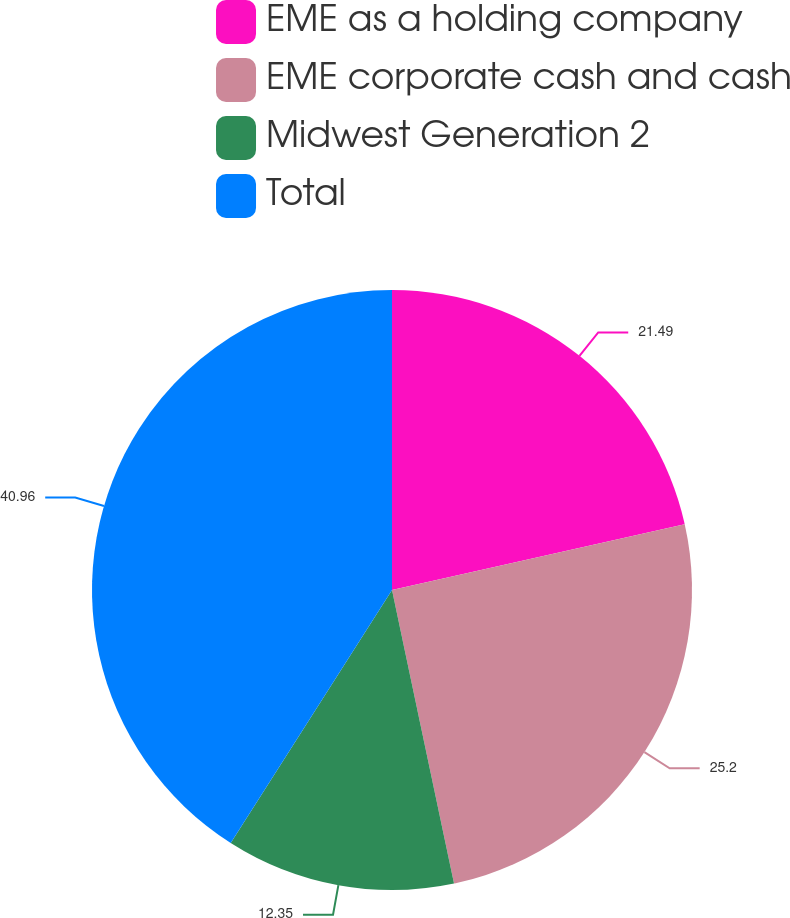<chart> <loc_0><loc_0><loc_500><loc_500><pie_chart><fcel>EME as a holding company<fcel>EME corporate cash and cash<fcel>Midwest Generation 2<fcel>Total<nl><fcel>21.49%<fcel>25.2%<fcel>12.35%<fcel>40.97%<nl></chart> 